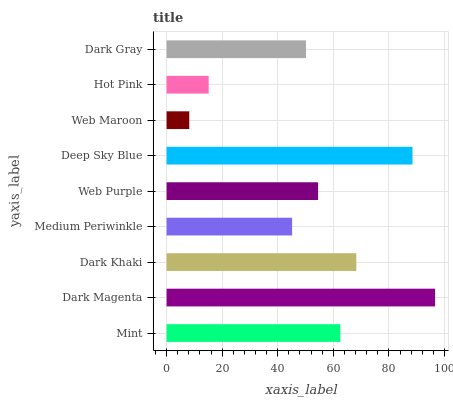Is Web Maroon the minimum?
Answer yes or no. Yes. Is Dark Magenta the maximum?
Answer yes or no. Yes. Is Dark Khaki the minimum?
Answer yes or no. No. Is Dark Khaki the maximum?
Answer yes or no. No. Is Dark Magenta greater than Dark Khaki?
Answer yes or no. Yes. Is Dark Khaki less than Dark Magenta?
Answer yes or no. Yes. Is Dark Khaki greater than Dark Magenta?
Answer yes or no. No. Is Dark Magenta less than Dark Khaki?
Answer yes or no. No. Is Web Purple the high median?
Answer yes or no. Yes. Is Web Purple the low median?
Answer yes or no. Yes. Is Deep Sky Blue the high median?
Answer yes or no. No. Is Mint the low median?
Answer yes or no. No. 